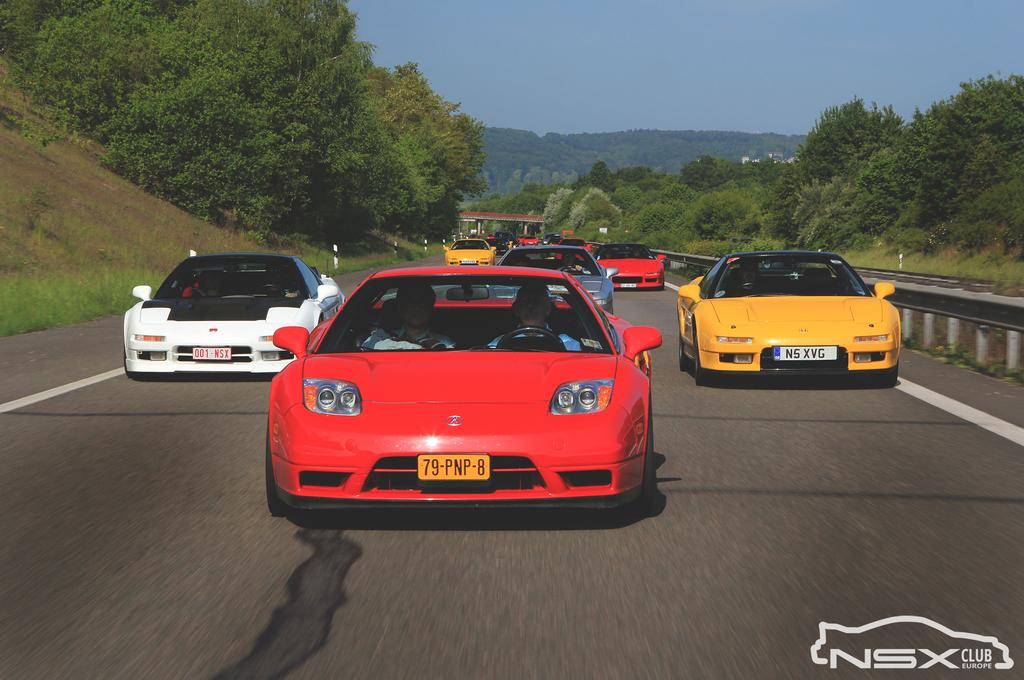What type of vehicles are in the image? There are sport cars in the image. Where are the sport cars located? The sport cars are on the road. What can be seen on either side of the road? There are trees and plants on either side of the road. What is visible above the road? The sky is visible above the road. What type of love can be seen between the sport cars in the image? There is no indication of love between the sport cars in the image; they are simply vehicles on the road. 